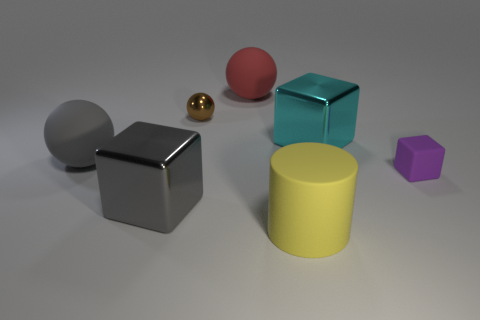Add 1 blue metal blocks. How many objects exist? 8 Subtract all blocks. How many objects are left? 4 Add 7 small purple rubber cubes. How many small purple rubber cubes are left? 8 Add 4 small matte things. How many small matte things exist? 5 Subtract 0 purple spheres. How many objects are left? 7 Subtract all cyan matte cylinders. Subtract all shiny blocks. How many objects are left? 5 